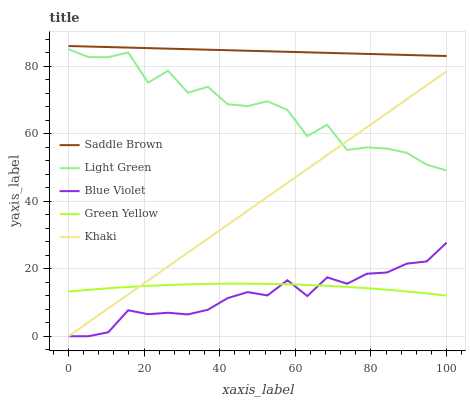Does Blue Violet have the minimum area under the curve?
Answer yes or no. Yes. Does Saddle Brown have the maximum area under the curve?
Answer yes or no. Yes. Does Green Yellow have the minimum area under the curve?
Answer yes or no. No. Does Green Yellow have the maximum area under the curve?
Answer yes or no. No. Is Khaki the smoothest?
Answer yes or no. Yes. Is Light Green the roughest?
Answer yes or no. Yes. Is Green Yellow the smoothest?
Answer yes or no. No. Is Green Yellow the roughest?
Answer yes or no. No. Does Blue Violet have the lowest value?
Answer yes or no. Yes. Does Green Yellow have the lowest value?
Answer yes or no. No. Does Saddle Brown have the highest value?
Answer yes or no. Yes. Does Khaki have the highest value?
Answer yes or no. No. Is Light Green less than Saddle Brown?
Answer yes or no. Yes. Is Light Green greater than Blue Violet?
Answer yes or no. Yes. Does Green Yellow intersect Khaki?
Answer yes or no. Yes. Is Green Yellow less than Khaki?
Answer yes or no. No. Is Green Yellow greater than Khaki?
Answer yes or no. No. Does Light Green intersect Saddle Brown?
Answer yes or no. No. 